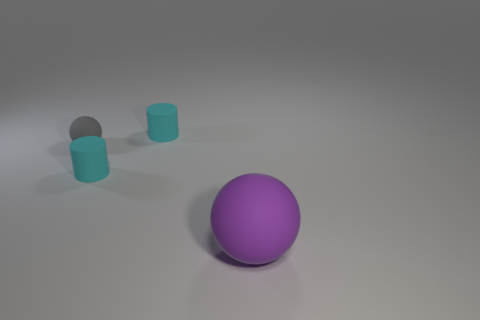Are there any other things that have the same size as the purple rubber object?
Provide a short and direct response. No. What number of other objects are the same size as the purple thing?
Keep it short and to the point. 0. Do the large purple object to the right of the tiny rubber sphere and the gray matte object have the same shape?
Provide a succinct answer. Yes. What is the material of the large sphere that is to the right of the tiny gray ball?
Your answer should be compact. Rubber. Is there a small green cube made of the same material as the large purple thing?
Offer a very short reply. No. How big is the gray matte sphere?
Keep it short and to the point. Small. What number of cyan objects are big shiny cylinders or small rubber objects?
Offer a very short reply. 2. How many tiny cyan matte things are the same shape as the small gray matte object?
Offer a very short reply. 0. How many cyan objects have the same size as the gray rubber object?
Your answer should be compact. 2. There is a purple object that is the same shape as the tiny gray object; what is it made of?
Keep it short and to the point. Rubber. 